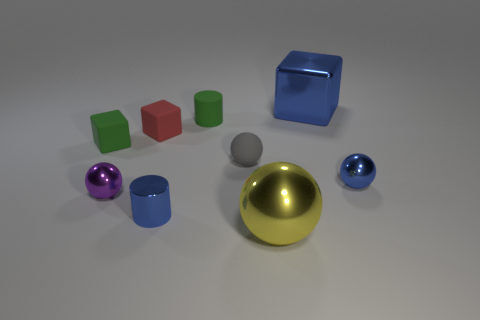Is there another matte object of the same shape as the purple object?
Offer a very short reply. Yes. What size is the green thing that is the same shape as the small red object?
Offer a terse response. Small. Does the ball that is on the left side of the rubber cylinder have the same material as the gray sphere?
Your response must be concise. No. There is a cylinder on the left side of the small green rubber object that is right of the blue thing that is left of the large yellow metal thing; how big is it?
Give a very brief answer. Small. What is the size of the green cube that is the same material as the small green cylinder?
Offer a very short reply. Small. There is a metal thing that is both in front of the purple sphere and right of the gray ball; what color is it?
Provide a succinct answer. Yellow. Do the tiny green object to the right of the tiny red rubber cube and the big shiny thing in front of the red cube have the same shape?
Provide a short and direct response. No. What is the tiny cylinder behind the gray matte object made of?
Provide a succinct answer. Rubber. What size is the cylinder that is the same color as the metal cube?
Your answer should be compact. Small. How many things are either cubes to the left of the metal cylinder or blue spheres?
Make the answer very short. 3. 